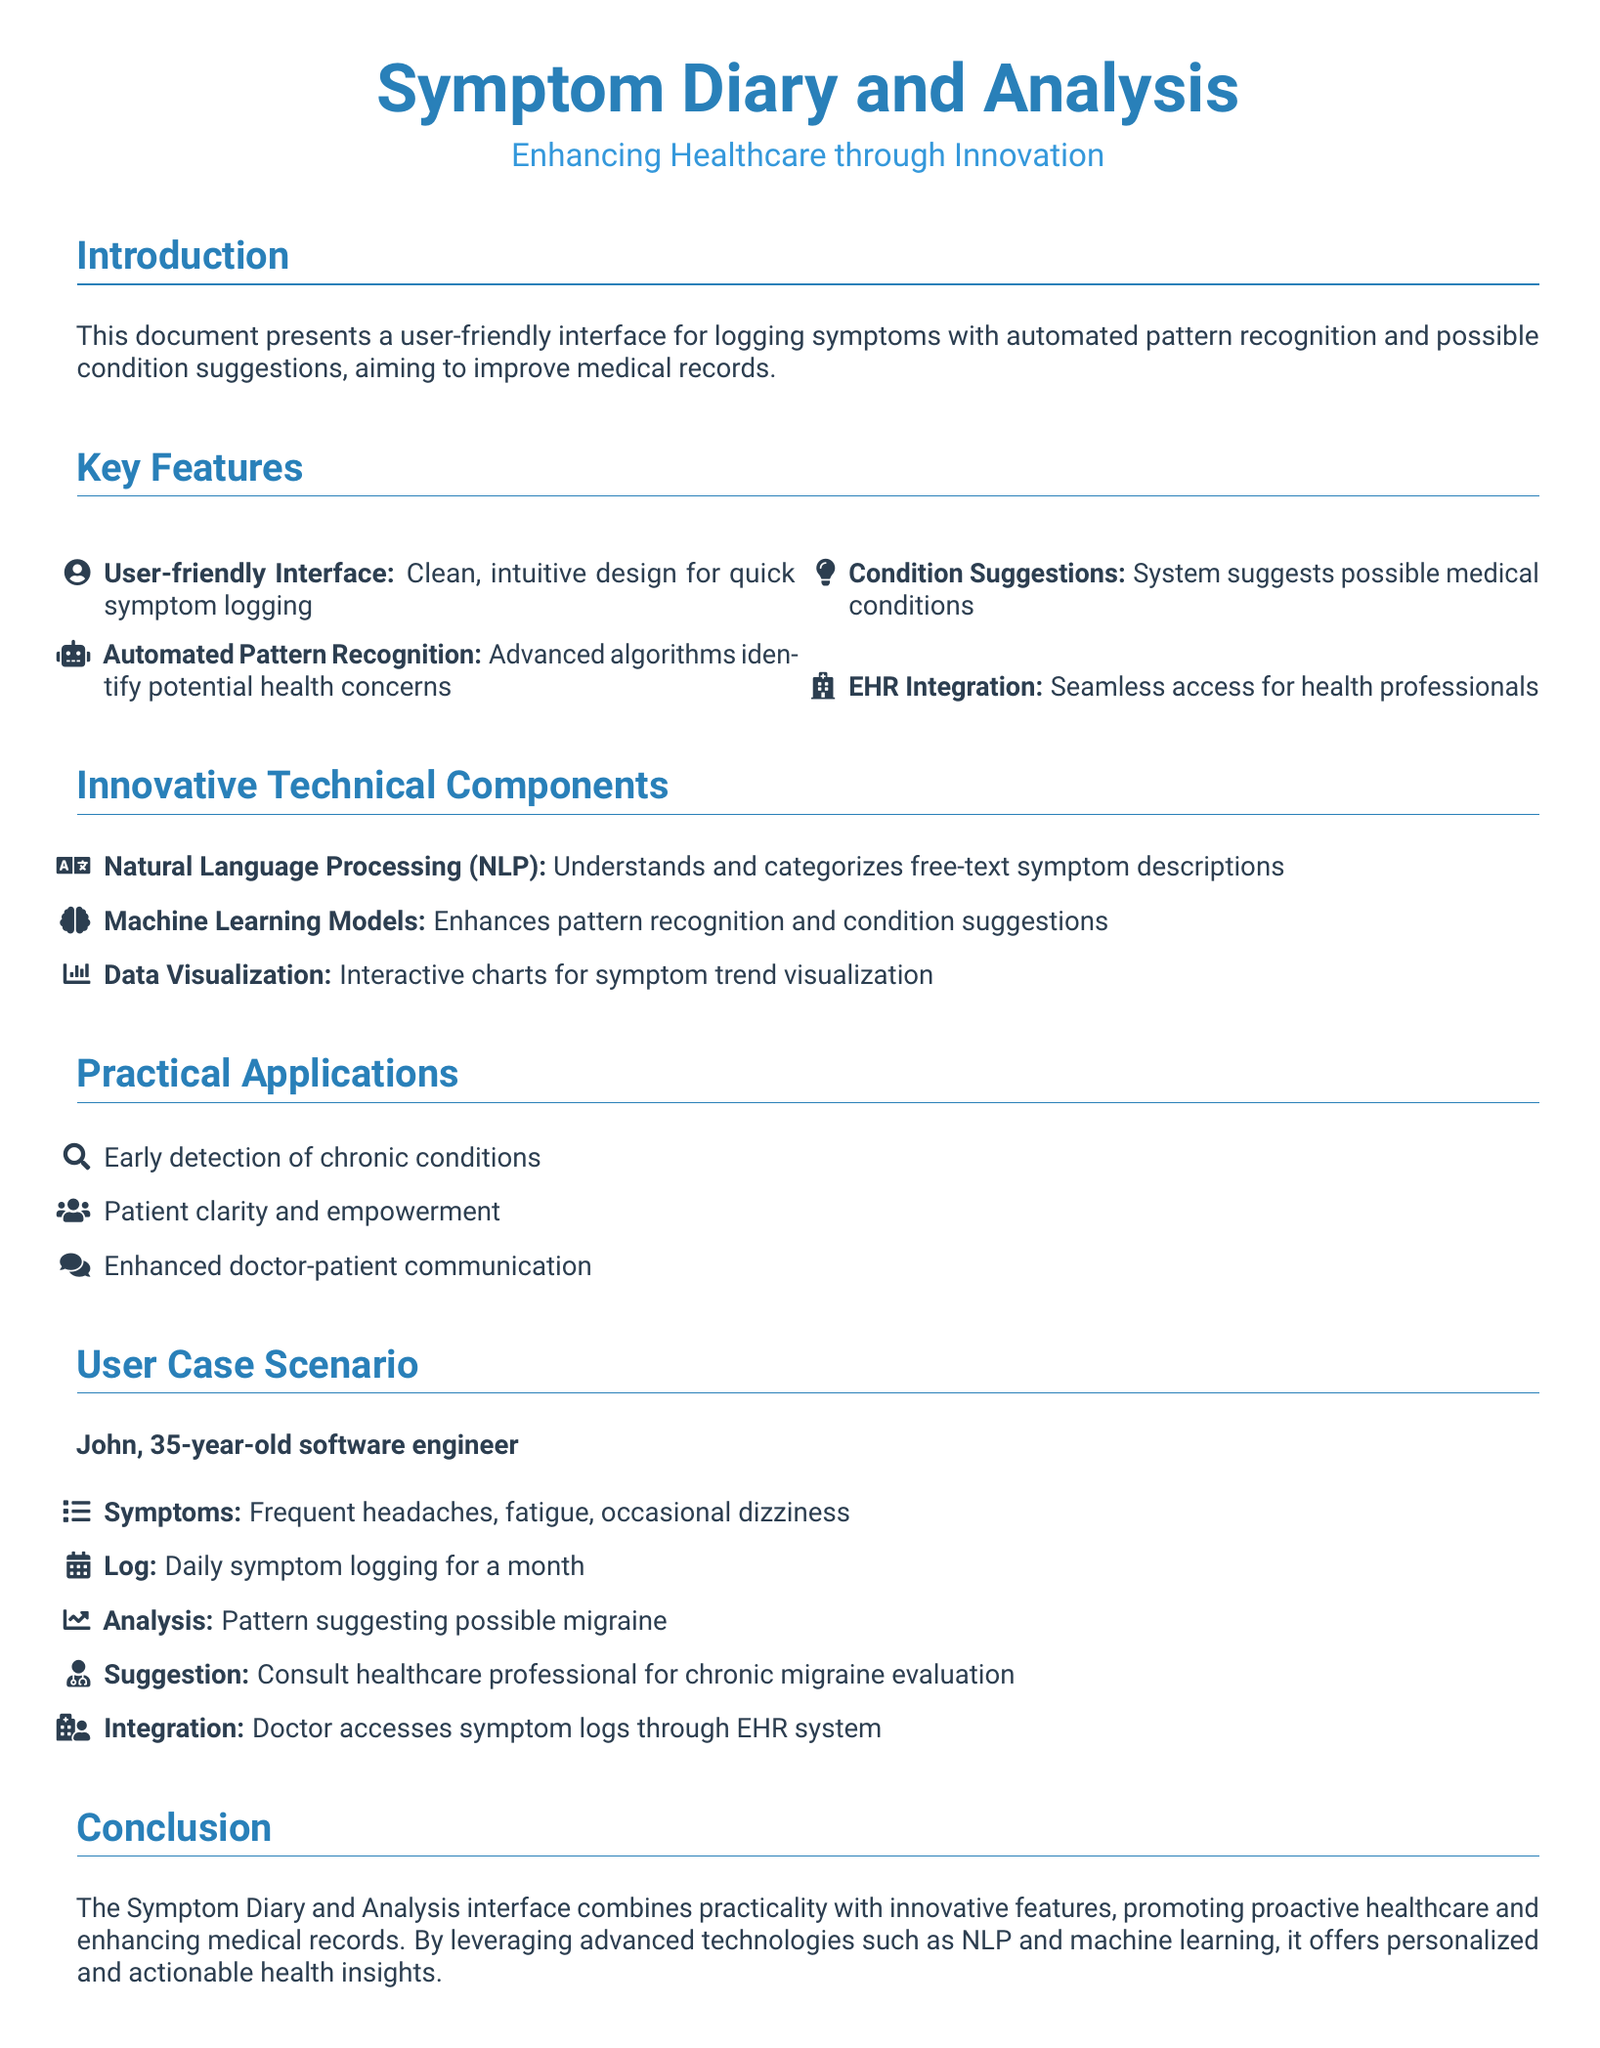What is the document's title? The title is the main heading that describes the content of the document.
Answer: Symptom Diary and Analysis What feature helps identify potential health concerns? This feature utilizes advanced algorithms to analyze the symptoms logged by users.
Answer: Automated Pattern Recognition What technology is used to understand free-text symptom descriptions? This technology categorizes symptoms described in natural language by users.
Answer: Natural Language Processing Who is the user case scenario based on? This specific individual illustrates how the system can be utilized for logging symptoms.
Answer: John What symptom did John log frequently? This symptom is one of the key issues that John experienced and recorded.
Answer: Headaches What relationship does the document aim to enhance? This relationship is essential for improving patient care and diagnosis transparency.
Answer: Doctor-patient communication How many symptoms does John report? This number indicates the total symptoms he logged in his use case.
Answer: Three What condition is suggested for John to consult a healthcare professional about? This possible health issue is derived from the analysis of his logged symptoms.
Answer: Chronic migraine What is the primary goal of the Symptom Diary and Analysis interface? This goal reflects the overarching intention of the system in healthcare.
Answer: Proactive healthcare 